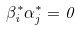Convert formula to latex. <formula><loc_0><loc_0><loc_500><loc_500>\beta _ { i } ^ { * } \alpha ^ { * } _ { j } = 0</formula> 